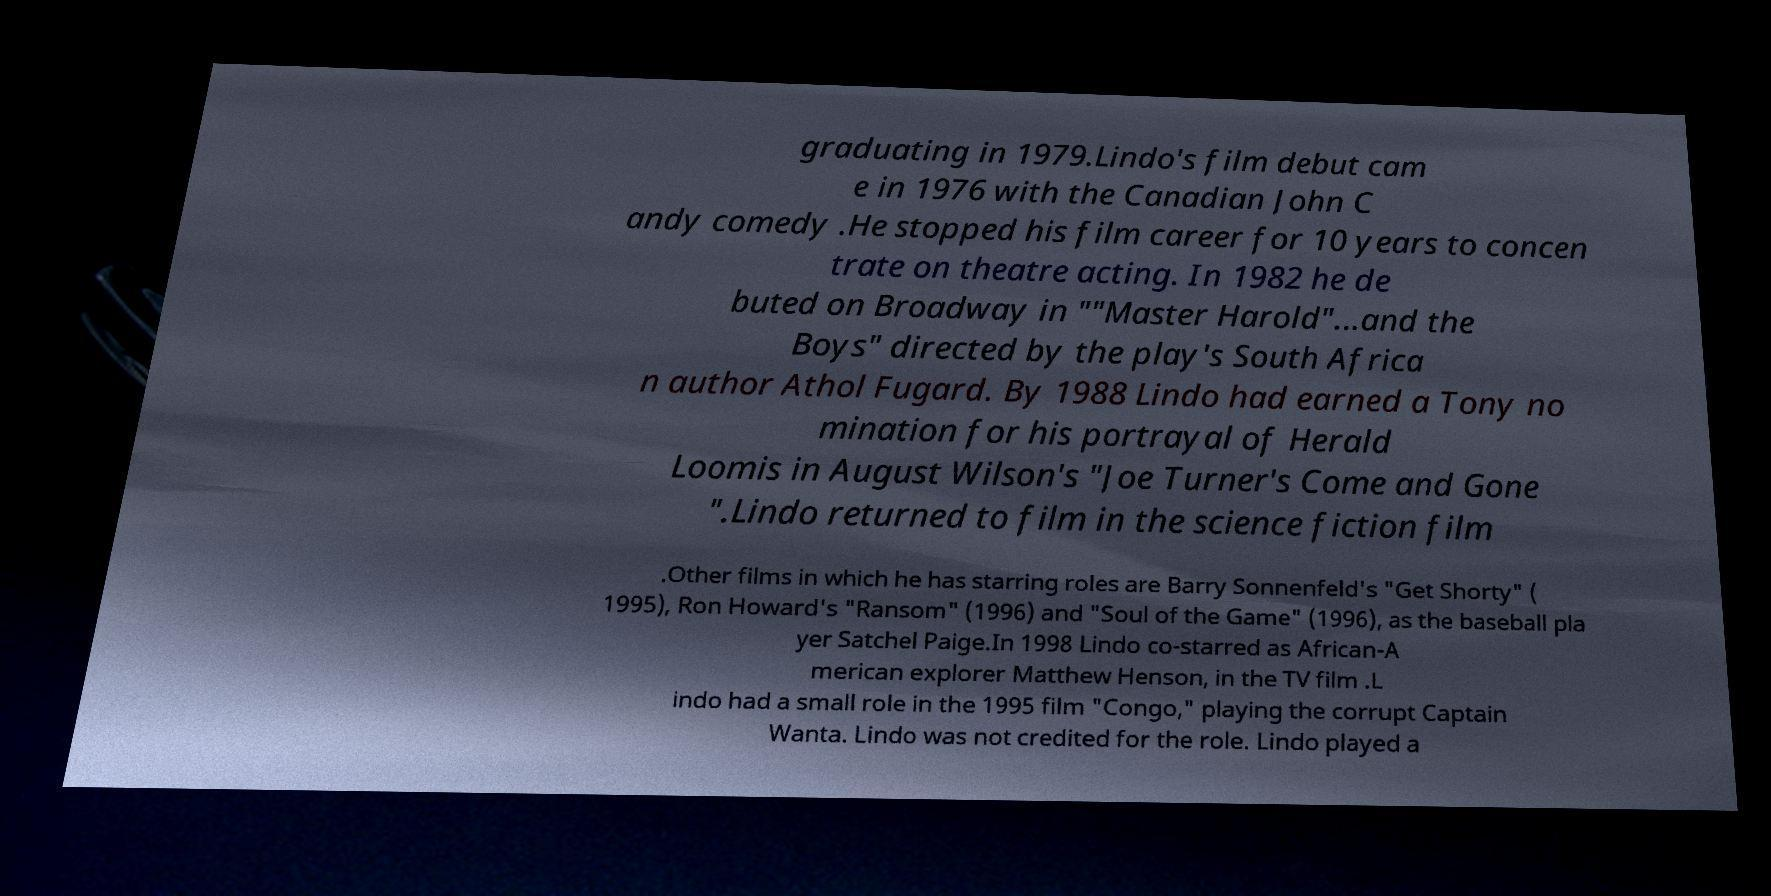Can you accurately transcribe the text from the provided image for me? graduating in 1979.Lindo's film debut cam e in 1976 with the Canadian John C andy comedy .He stopped his film career for 10 years to concen trate on theatre acting. In 1982 he de buted on Broadway in ""Master Harold"...and the Boys" directed by the play's South Africa n author Athol Fugard. By 1988 Lindo had earned a Tony no mination for his portrayal of Herald Loomis in August Wilson's "Joe Turner's Come and Gone ".Lindo returned to film in the science fiction film .Other films in which he has starring roles are Barry Sonnenfeld's "Get Shorty" ( 1995), Ron Howard's "Ransom" (1996) and "Soul of the Game" (1996), as the baseball pla yer Satchel Paige.In 1998 Lindo co-starred as African-A merican explorer Matthew Henson, in the TV film .L indo had a small role in the 1995 film "Congo," playing the corrupt Captain Wanta. Lindo was not credited for the role. Lindo played a 